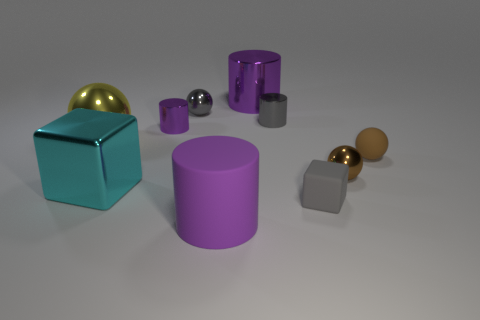How many purple cylinders must be subtracted to get 1 purple cylinders? 2 Subtract all blue cubes. How many purple cylinders are left? 3 Subtract all purple cylinders. How many cylinders are left? 1 Subtract 1 balls. How many balls are left? 3 Subtract all brown cylinders. Subtract all cyan balls. How many cylinders are left? 4 Subtract all balls. How many objects are left? 6 Subtract 0 cyan cylinders. How many objects are left? 10 Subtract all small brown shiny spheres. Subtract all brown matte spheres. How many objects are left? 8 Add 8 tiny rubber blocks. How many tiny rubber blocks are left? 9 Add 1 purple metal cylinders. How many purple metal cylinders exist? 3 